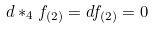Convert formula to latex. <formula><loc_0><loc_0><loc_500><loc_500>d * _ { 4 } f _ { ( 2 ) } = d f _ { ( 2 ) } = 0</formula> 